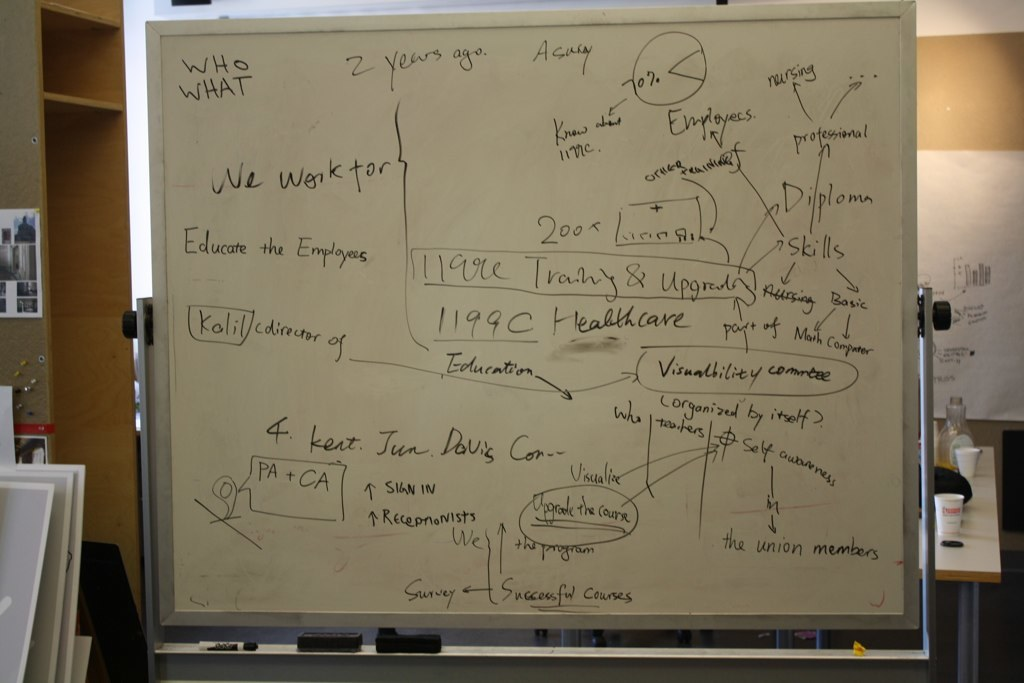What might be the purpose of including '1199C Healthcare' on this board? '1199C Healthcare' likely refers to specific initiatives or programs under the 1199C labor union, focusing on education and training for healthcare employees, indicating collaboration or support as part of these developmental efforts. How would this kind of training affect the employees? Such training would probably enhance employees' professional skills, improve job performance, and provide greater career advancement opportunities, resulting in higher job satisfaction and efficiency within the healthcare sector. 